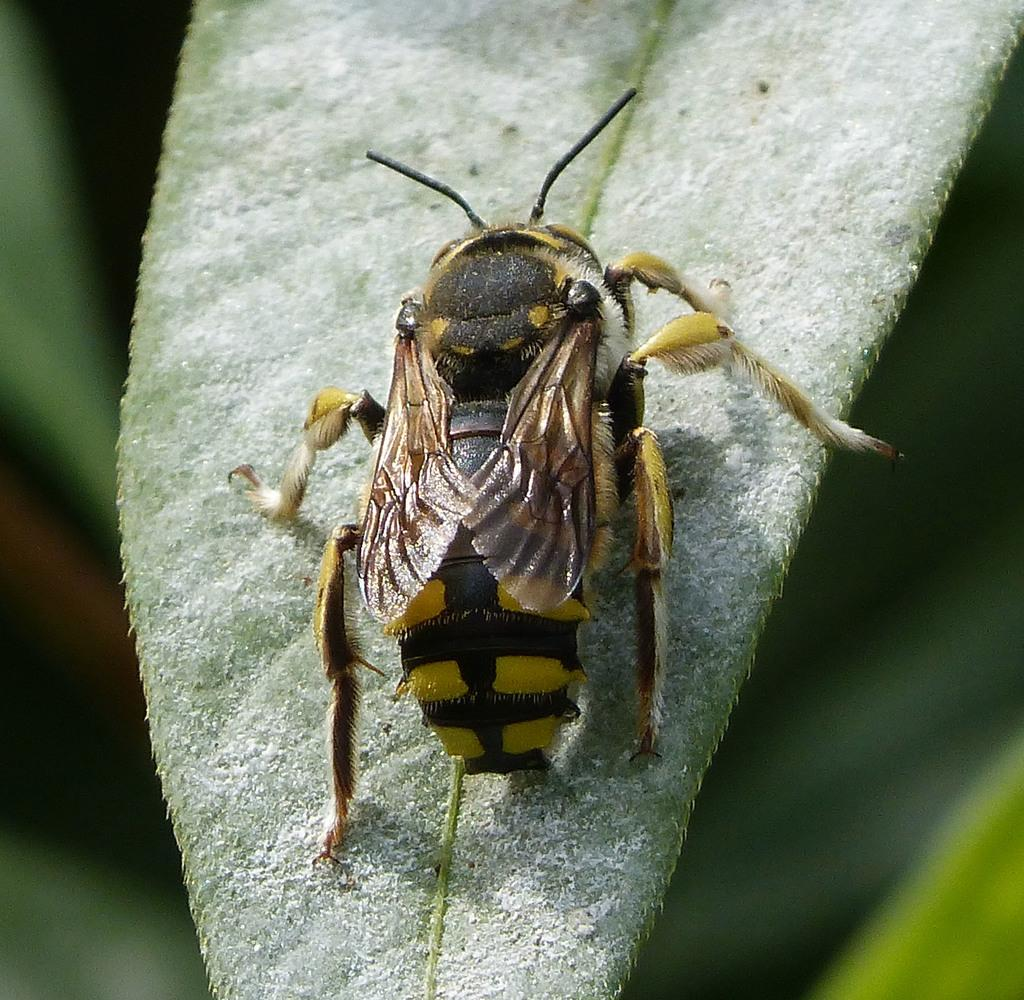What is present on the leaf in the image? There is an insect on the leaf in the image. Can you describe the insect's location in the image? The insect is on a leaf in the image. What can be observed about the background of the image? The background of the image is blurry. What type of stone is the insect using to climb in the image? There is no stone present in the image; the insect is on a leaf. 